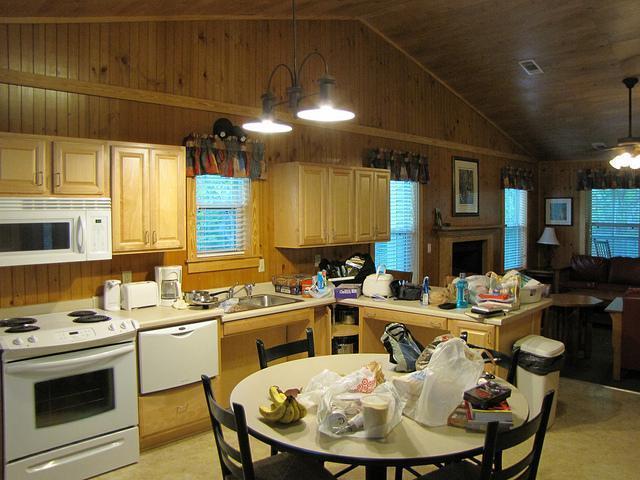What did the occupants of this home likely just get done doing?
Indicate the correct response by choosing from the four available options to answer the question.
Options: Library visit, school, swimming, shop. Shop. What is on top of the dining table?
Choose the correct response and explain in the format: 'Answer: answer
Rationale: rationale.'
Options: Cat, bananas, fish heads, yule log. Answer: bananas.
Rationale: There is a bunch of bananas on top of the dining table. 